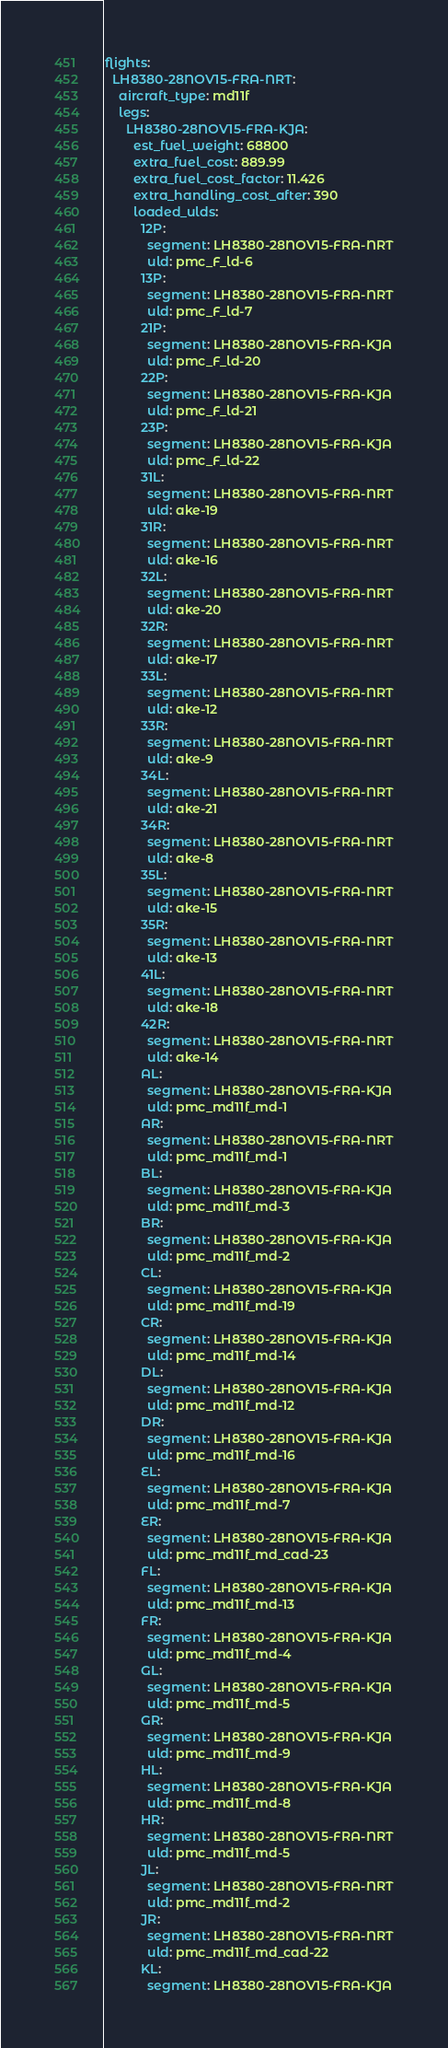Convert code to text. <code><loc_0><loc_0><loc_500><loc_500><_YAML_>flights:
  LH8380-28NOV15-FRA-NRT:
    aircraft_type: md11f
    legs:
      LH8380-28NOV15-FRA-KJA:
        est_fuel_weight: 68800
        extra_fuel_cost: 889.99
        extra_fuel_cost_factor: 11.426
        extra_handling_cost_after: 390
        loaded_ulds:
          12P:
            segment: LH8380-28NOV15-FRA-NRT
            uld: pmc_F_ld-6
          13P:
            segment: LH8380-28NOV15-FRA-NRT
            uld: pmc_F_ld-7
          21P:
            segment: LH8380-28NOV15-FRA-KJA
            uld: pmc_F_ld-20
          22P:
            segment: LH8380-28NOV15-FRA-KJA
            uld: pmc_F_ld-21
          23P:
            segment: LH8380-28NOV15-FRA-KJA
            uld: pmc_F_ld-22
          31L:
            segment: LH8380-28NOV15-FRA-NRT
            uld: ake-19
          31R:
            segment: LH8380-28NOV15-FRA-NRT
            uld: ake-16
          32L:
            segment: LH8380-28NOV15-FRA-NRT
            uld: ake-20
          32R:
            segment: LH8380-28NOV15-FRA-NRT
            uld: ake-17
          33L:
            segment: LH8380-28NOV15-FRA-NRT
            uld: ake-12
          33R:
            segment: LH8380-28NOV15-FRA-NRT
            uld: ake-9
          34L:
            segment: LH8380-28NOV15-FRA-NRT
            uld: ake-21
          34R:
            segment: LH8380-28NOV15-FRA-NRT
            uld: ake-8
          35L:
            segment: LH8380-28NOV15-FRA-NRT
            uld: ake-15
          35R:
            segment: LH8380-28NOV15-FRA-NRT
            uld: ake-13
          41L:
            segment: LH8380-28NOV15-FRA-NRT
            uld: ake-18
          42R:
            segment: LH8380-28NOV15-FRA-NRT
            uld: ake-14
          AL:
            segment: LH8380-28NOV15-FRA-KJA
            uld: pmc_md11f_md-1
          AR:
            segment: LH8380-28NOV15-FRA-NRT
            uld: pmc_md11f_md-1
          BL:
            segment: LH8380-28NOV15-FRA-KJA
            uld: pmc_md11f_md-3
          BR:
            segment: LH8380-28NOV15-FRA-KJA
            uld: pmc_md11f_md-2
          CL:
            segment: LH8380-28NOV15-FRA-KJA
            uld: pmc_md11f_md-19
          CR:
            segment: LH8380-28NOV15-FRA-KJA
            uld: pmc_md11f_md-14
          DL:
            segment: LH8380-28NOV15-FRA-KJA
            uld: pmc_md11f_md-12
          DR:
            segment: LH8380-28NOV15-FRA-KJA
            uld: pmc_md11f_md-16
          EL:
            segment: LH8380-28NOV15-FRA-KJA
            uld: pmc_md11f_md-7
          ER:
            segment: LH8380-28NOV15-FRA-KJA
            uld: pmc_md11f_md_cad-23
          FL:
            segment: LH8380-28NOV15-FRA-KJA
            uld: pmc_md11f_md-13
          FR:
            segment: LH8380-28NOV15-FRA-KJA
            uld: pmc_md11f_md-4
          GL:
            segment: LH8380-28NOV15-FRA-KJA
            uld: pmc_md11f_md-5
          GR:
            segment: LH8380-28NOV15-FRA-KJA
            uld: pmc_md11f_md-9
          HL:
            segment: LH8380-28NOV15-FRA-KJA
            uld: pmc_md11f_md-8
          HR:
            segment: LH8380-28NOV15-FRA-NRT
            uld: pmc_md11f_md-5
          JL:
            segment: LH8380-28NOV15-FRA-NRT
            uld: pmc_md11f_md-2
          JR:
            segment: LH8380-28NOV15-FRA-NRT
            uld: pmc_md11f_md_cad-22
          KL:
            segment: LH8380-28NOV15-FRA-KJA</code> 